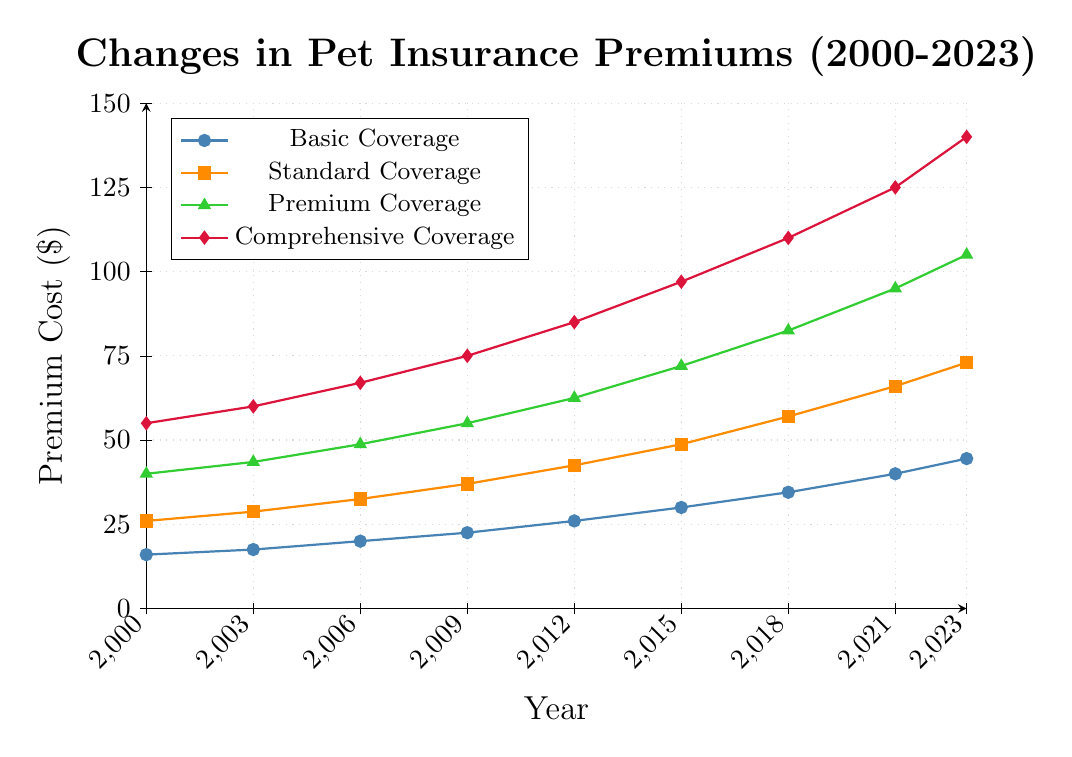What coverage type had the highest premium cost in 2023? Locate the year 2023 on the x-axis and observe the plotted points for each coverage type. The Comprehensive Coverage (diamond marker) is the highest point.
Answer: Comprehensive Coverage How much did Basic Coverage cost increase from 2000 to 2023? Find Basic Coverage values for the years 2000 and 2023. The values are 15.99 and 44.50, respectively. Compute the difference: 44.50 - 15.99 = 28.51
Answer: 28.51 Which year saw the largest increase in Premium Coverage costs? Look at the values for Premium Coverage in the data and calculate the annual increases. The largest increase is from 2009 (54.99) to 2012 (62.50). Difference: 62.50 - 54.99 = 7.51
Answer: 2012 What was the average cost of Standard Coverage over the entire period? List all Standard Coverage values: 25.99, 28.75, 32.50, 36.99, 42.50, 48.75, 56.99, 65.99, 72.99. Compute the sum: 411.45. Divide by the number of values: 411.45 / 9 ≈ 45.72
Answer: 45.72 During which time period did Comprehensive Coverage see a consistent rise without any decreases? Examine the values for Comprehensive Coverage: 54.99 (2000), 59.99 (2003), 66.99 (2006), 74.99 (2009), 84.99 (2012), 96.99 (2015), 109.99 (2018), 124.99 (2021), 139.99 (2023). It consistently increased every period.
Answer: 2000-2023 In 2015, how much more did Premium Coverage cost compared to Basic Coverage? Find the values for Premium Coverage (71.99) and Basic Coverage (29.99) in 2015. Calculate the difference: 71.99 - 29.99 = 42.00
Answer: 42.00 Is the rate of cost increase for Standard Coverage faster or slower than Basic Coverage over the period? Calculate total increase for each coverage: Standard (72.99 - 25.99 = 47.00), Basic (44.50 - 15.99 = 28.51). Standard Coverage has a higher increase, hence a faster rate.
Answer: Faster What is the most significant visual characteristic distinguishing Comprehensive Coverage in the plot? Identify visual attributes: Comprehensive Coverage is represented by red diamonds, which stand out highest across all years.
Answer: Red diamonds By how much did the cost of Comprehensive Coverage increase from 2003 to 2009? Find values for 2003 (59.99) and 2009 (74.99). Difference is: 74.99 - 59.99 = 15.00
Answer: 15.00 In which year did Basic Coverage cost more than $35? Find the point where Basic Coverage first exceeds $35. This occurs in 2018 with a value of 34.50 and then firmly in 2021 at 39.99. Hence, 2021 is the first year.
Answer: 2021 